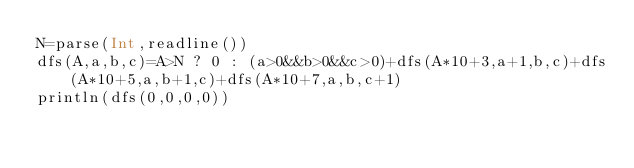Convert code to text. <code><loc_0><loc_0><loc_500><loc_500><_Julia_>N=parse(Int,readline())
dfs(A,a,b,c)=A>N ? 0 : (a>0&&b>0&&c>0)+dfs(A*10+3,a+1,b,c)+dfs(A*10+5,a,b+1,c)+dfs(A*10+7,a,b,c+1)
println(dfs(0,0,0,0))</code> 